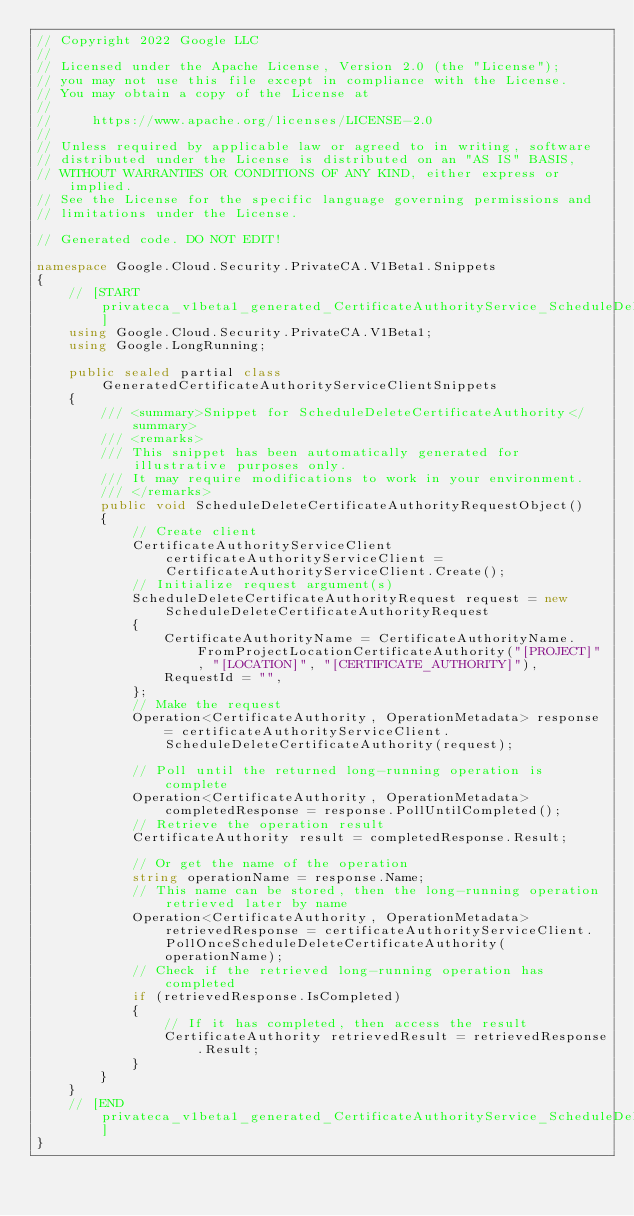<code> <loc_0><loc_0><loc_500><loc_500><_C#_>// Copyright 2022 Google LLC
//
// Licensed under the Apache License, Version 2.0 (the "License");
// you may not use this file except in compliance with the License.
// You may obtain a copy of the License at
//
//     https://www.apache.org/licenses/LICENSE-2.0
//
// Unless required by applicable law or agreed to in writing, software
// distributed under the License is distributed on an "AS IS" BASIS,
// WITHOUT WARRANTIES OR CONDITIONS OF ANY KIND, either express or implied.
// See the License for the specific language governing permissions and
// limitations under the License.

// Generated code. DO NOT EDIT!

namespace Google.Cloud.Security.PrivateCA.V1Beta1.Snippets
{
    // [START privateca_v1beta1_generated_CertificateAuthorityService_ScheduleDeleteCertificateAuthority_sync]
    using Google.Cloud.Security.PrivateCA.V1Beta1;
    using Google.LongRunning;

    public sealed partial class GeneratedCertificateAuthorityServiceClientSnippets
    {
        /// <summary>Snippet for ScheduleDeleteCertificateAuthority</summary>
        /// <remarks>
        /// This snippet has been automatically generated for illustrative purposes only.
        /// It may require modifications to work in your environment.
        /// </remarks>
        public void ScheduleDeleteCertificateAuthorityRequestObject()
        {
            // Create client
            CertificateAuthorityServiceClient certificateAuthorityServiceClient = CertificateAuthorityServiceClient.Create();
            // Initialize request argument(s)
            ScheduleDeleteCertificateAuthorityRequest request = new ScheduleDeleteCertificateAuthorityRequest
            {
                CertificateAuthorityName = CertificateAuthorityName.FromProjectLocationCertificateAuthority("[PROJECT]", "[LOCATION]", "[CERTIFICATE_AUTHORITY]"),
                RequestId = "",
            };
            // Make the request
            Operation<CertificateAuthority, OperationMetadata> response = certificateAuthorityServiceClient.ScheduleDeleteCertificateAuthority(request);

            // Poll until the returned long-running operation is complete
            Operation<CertificateAuthority, OperationMetadata> completedResponse = response.PollUntilCompleted();
            // Retrieve the operation result
            CertificateAuthority result = completedResponse.Result;

            // Or get the name of the operation
            string operationName = response.Name;
            // This name can be stored, then the long-running operation retrieved later by name
            Operation<CertificateAuthority, OperationMetadata> retrievedResponse = certificateAuthorityServiceClient.PollOnceScheduleDeleteCertificateAuthority(operationName);
            // Check if the retrieved long-running operation has completed
            if (retrievedResponse.IsCompleted)
            {
                // If it has completed, then access the result
                CertificateAuthority retrievedResult = retrievedResponse.Result;
            }
        }
    }
    // [END privateca_v1beta1_generated_CertificateAuthorityService_ScheduleDeleteCertificateAuthority_sync]
}
</code> 